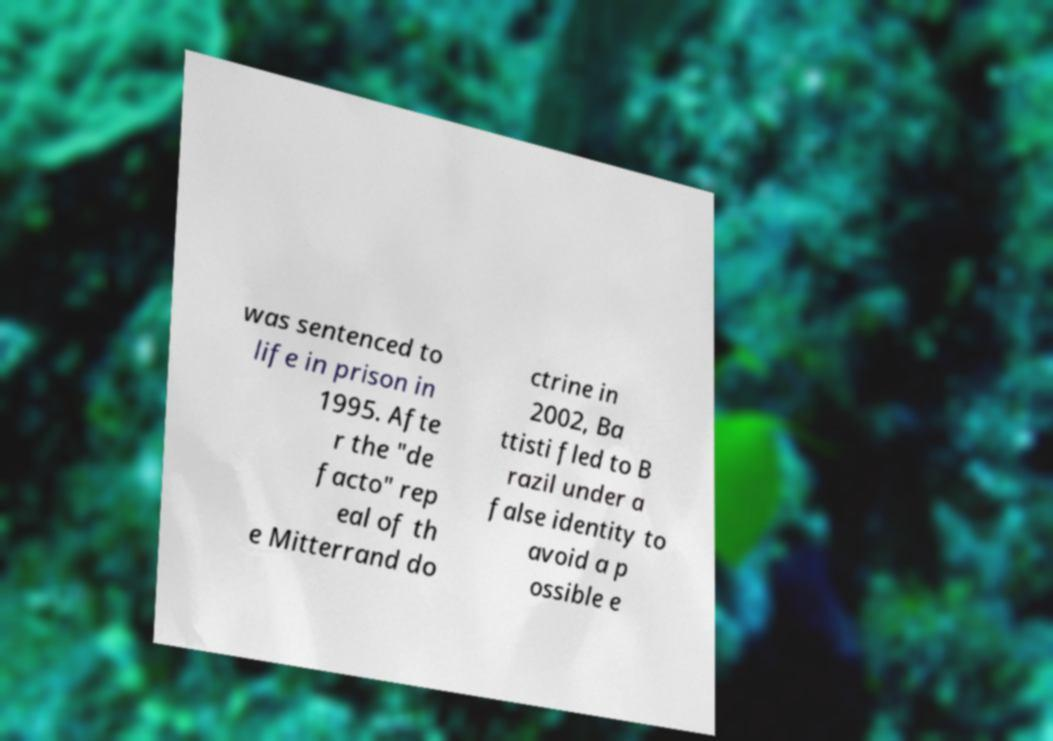There's text embedded in this image that I need extracted. Can you transcribe it verbatim? was sentenced to life in prison in 1995. Afte r the "de facto" rep eal of th e Mitterrand do ctrine in 2002, Ba ttisti fled to B razil under a false identity to avoid a p ossible e 